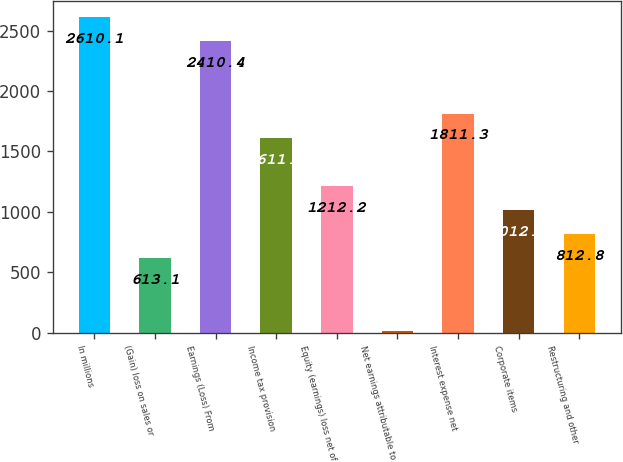<chart> <loc_0><loc_0><loc_500><loc_500><bar_chart><fcel>In millions<fcel>(Gain) loss on sales or<fcel>Earnings (Loss) From<fcel>Income tax provision<fcel>Equity (earnings) loss net of<fcel>Net earnings attributable to<fcel>Interest expense net<fcel>Corporate items<fcel>Restructuring and other<nl><fcel>2610.1<fcel>613.1<fcel>2410.4<fcel>1611.6<fcel>1212.2<fcel>14<fcel>1811.3<fcel>1012.5<fcel>812.8<nl></chart> 